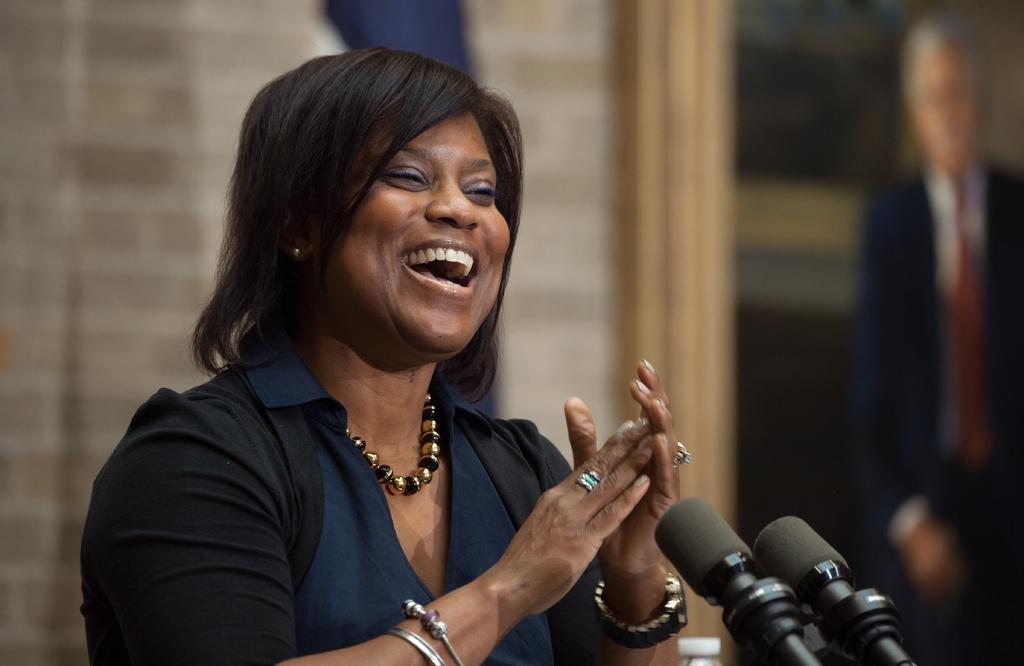What is the main subject of the image? There is a person in the image. What objects are associated with the person in the image? There are microphones in the image. What additional item can be seen in the image? There is a photo frame in the image. What type of soap is being used by the person in the image? There is no soap present in the image. How is the knot tied by the person in the image? There is no knot present in the image. 